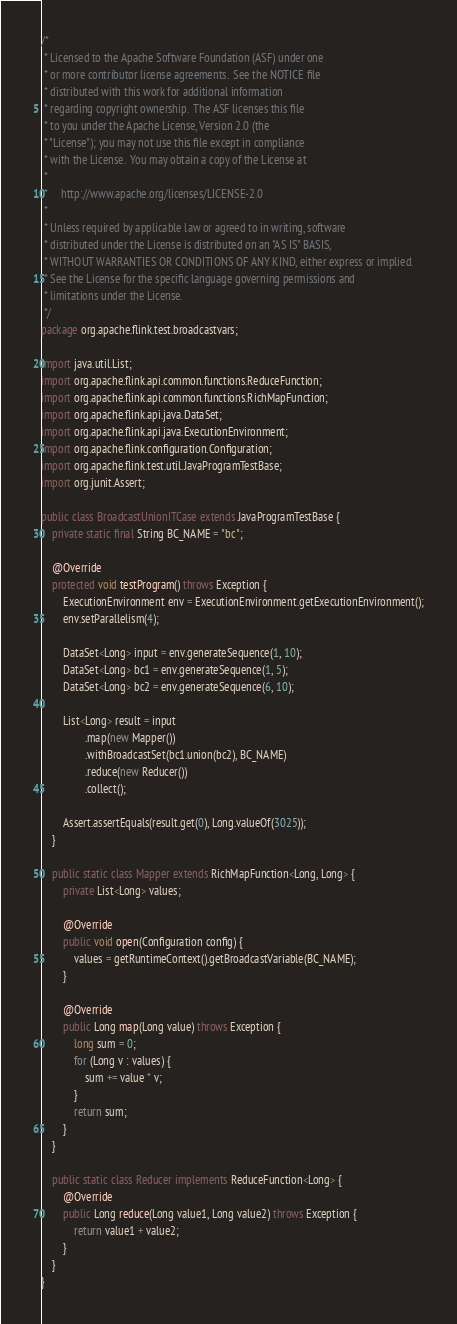Convert code to text. <code><loc_0><loc_0><loc_500><loc_500><_Java_>/*
 * Licensed to the Apache Software Foundation (ASF) under one
 * or more contributor license agreements.  See the NOTICE file
 * distributed with this work for additional information
 * regarding copyright ownership.  The ASF licenses this file
 * to you under the Apache License, Version 2.0 (the
 * "License"); you may not use this file except in compliance
 * with the License.  You may obtain a copy of the License at
 *
 *     http://www.apache.org/licenses/LICENSE-2.0
 *
 * Unless required by applicable law or agreed to in writing, software
 * distributed under the License is distributed on an "AS IS" BASIS,
 * WITHOUT WARRANTIES OR CONDITIONS OF ANY KIND, either express or implied.
 * See the License for the specific language governing permissions and
 * limitations under the License.
 */
package org.apache.flink.test.broadcastvars;

import java.util.List;
import org.apache.flink.api.common.functions.ReduceFunction;
import org.apache.flink.api.common.functions.RichMapFunction;
import org.apache.flink.api.java.DataSet;
import org.apache.flink.api.java.ExecutionEnvironment;
import org.apache.flink.configuration.Configuration;
import org.apache.flink.test.util.JavaProgramTestBase;
import org.junit.Assert;

public class BroadcastUnionITCase extends JavaProgramTestBase {
	private static final String BC_NAME = "bc";

	@Override
	protected void testProgram() throws Exception {
		ExecutionEnvironment env = ExecutionEnvironment.getExecutionEnvironment();
		env.setParallelism(4);

		DataSet<Long> input = env.generateSequence(1, 10);
		DataSet<Long> bc1 = env.generateSequence(1, 5);
		DataSet<Long> bc2 = env.generateSequence(6, 10);

		List<Long> result = input
				.map(new Mapper())
				.withBroadcastSet(bc1.union(bc2), BC_NAME)
				.reduce(new Reducer())
				.collect();
		
		Assert.assertEquals(result.get(0), Long.valueOf(3025));
	}

	public static class Mapper extends RichMapFunction<Long, Long> {
		private List<Long> values;

		@Override
		public void open(Configuration config) {
			values = getRuntimeContext().getBroadcastVariable(BC_NAME);
		}

		@Override
		public Long map(Long value) throws Exception {
			long sum = 0;
			for (Long v : values) {
				sum += value * v;
			}
			return sum;
		}
	}

	public static class Reducer implements ReduceFunction<Long> {
		@Override
		public Long reduce(Long value1, Long value2) throws Exception {
			return value1 + value2;
		}
	}
}
</code> 